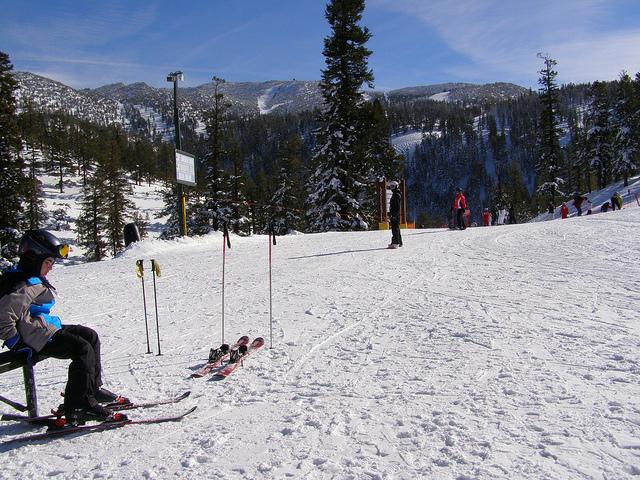Why is the boy wearing a coat?
Be succinct. Cold. Has anyone skied here previously?
Write a very short answer. Yes. Is this area flat?
Concise answer only. No. What color is the sign?
Quick response, please. White. 